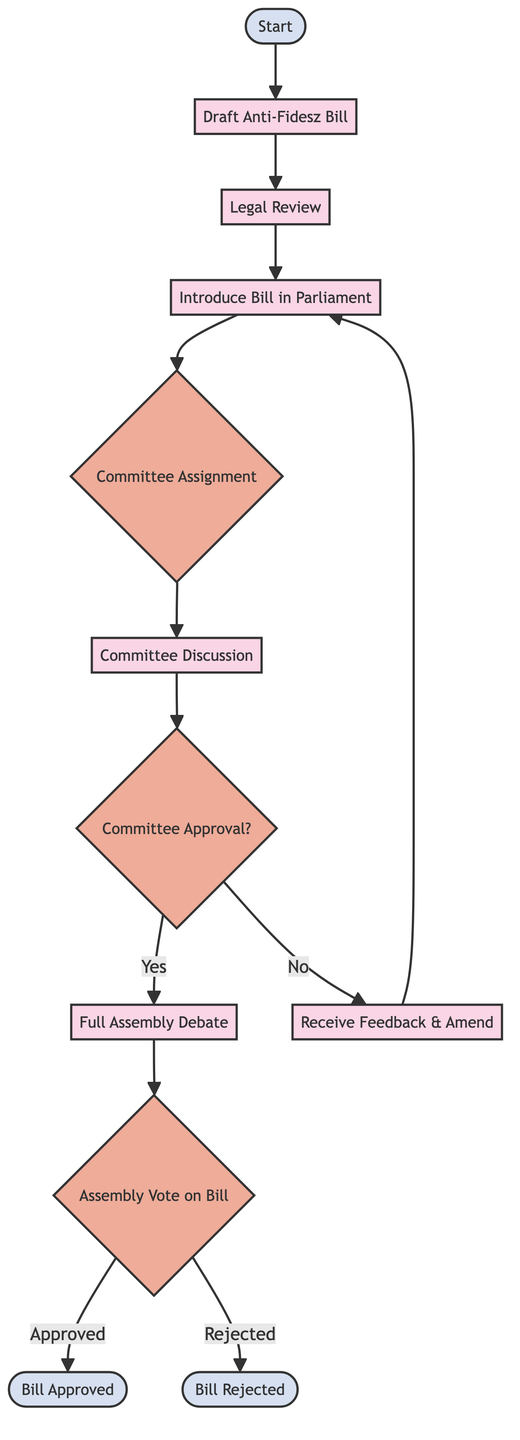What is the first step in the legislation process? The first step is represented by the "Start" node, which initiates the legislation process for an anti-Fidesz bill.
Answer: Start How many decision points are present in the diagram? The diagram contains three decision points: Committee Assignment, Committee Approval, and Assembly Vote on Bill.
Answer: 3 What follows the "Full Assembly Debate" in the process? After the "Full Assembly Debate," the next step is the "Assembly Vote on Bill" which determines if the bill will be approved or rejected.
Answer: Assembly Vote on Bill If the bill is not approved in the committee, what is the next step? If the committee does not approve the bill, the process loops back to "Receive Feedback & Amend," indicating amendments are necessary before reintroducing the bill.
Answer: Receive Feedback & Amend What happens if the Assembly Vote is approved? If the Assembly Vote is approved, the final step in the process is the "Bill Approved," which means the bill is completed and will proceed to implementation.
Answer: Bill Approved What is the purpose of the "Legal Review" step? The "Legal Review" step ensures that the drafted bill complies with Hungarian law before it is presented to Parliament.
Answer: Ensure legal compliance Where does the process lead after "Committee Approval?" After "Committee Approval," if it is approved, the process leads to "Full Assembly Debate" for further discussion of the bill. If not approved, it goes to "Receive Feedback & Amend."
Answer: Full Assembly Debate or Receive Feedback & Amend What type of node is "Committee Assignment"? The "Committee Assignment" node is a decision node that determines the subsequent steps based on the committee's assignment to the bill.
Answer: Decision node 